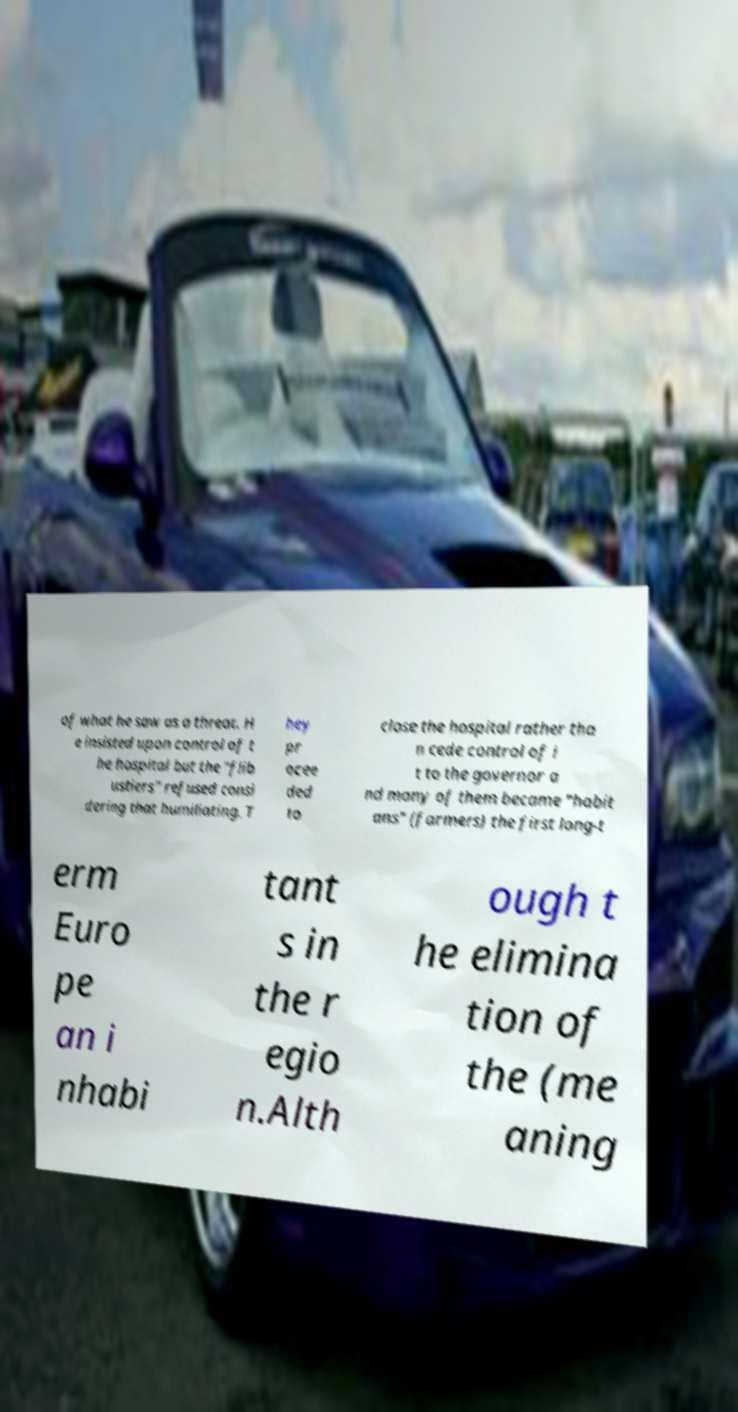For documentation purposes, I need the text within this image transcribed. Could you provide that? of what he saw as a threat. H e insisted upon control of t he hospital but the "flib ustiers" refused consi dering that humiliating. T hey pr ocee ded to close the hospital rather tha n cede control of i t to the governor a nd many of them became "habit ans" (farmers) the first long-t erm Euro pe an i nhabi tant s in the r egio n.Alth ough t he elimina tion of the (me aning 